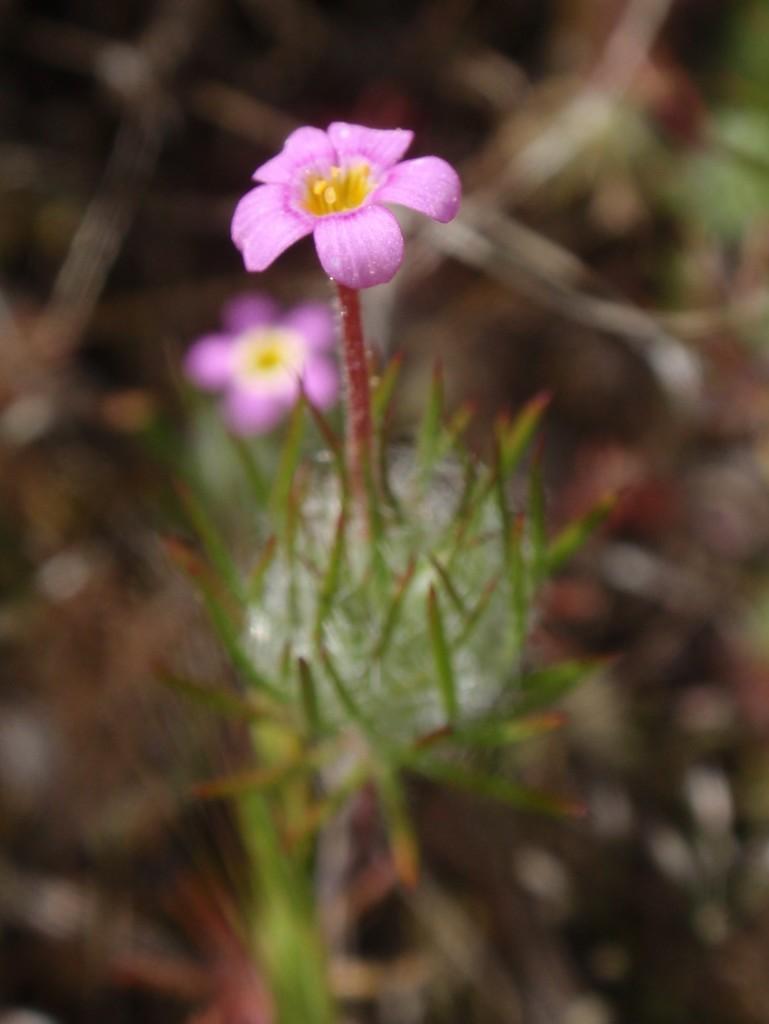In one or two sentences, can you explain what this image depicts? In this image, we can see flowers on the blur background. 